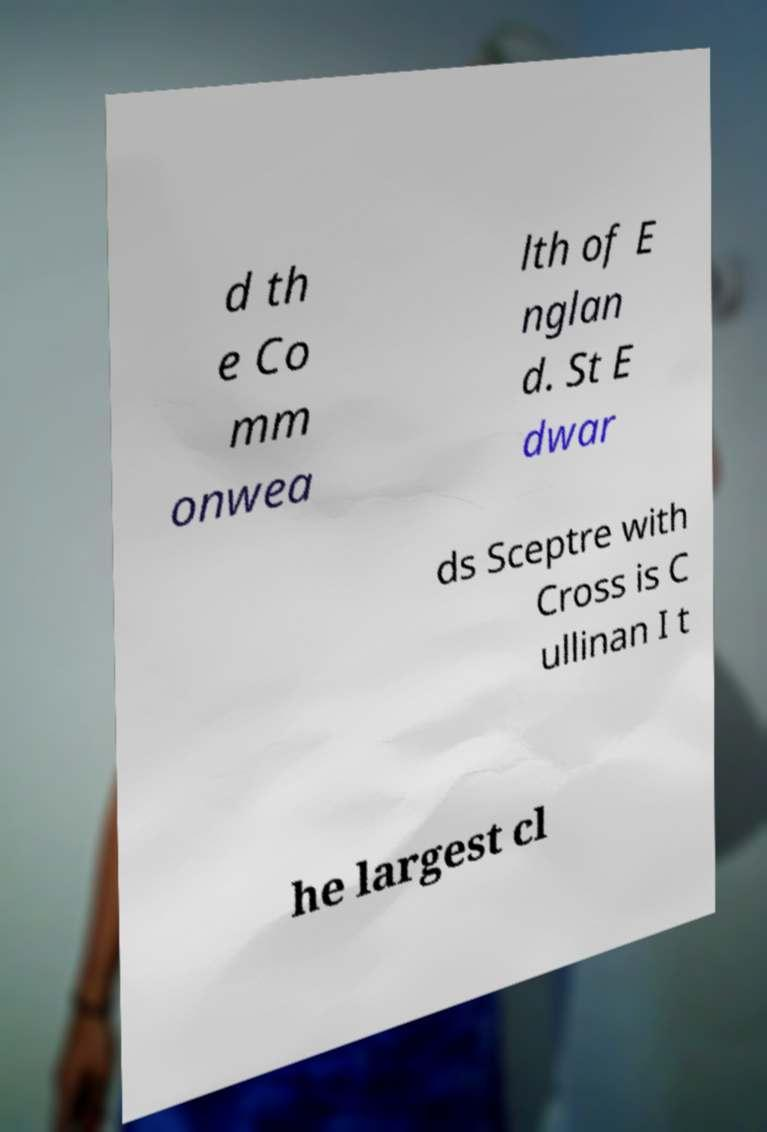Can you read and provide the text displayed in the image?This photo seems to have some interesting text. Can you extract and type it out for me? d th e Co mm onwea lth of E nglan d. St E dwar ds Sceptre with Cross is C ullinan I t he largest cl 